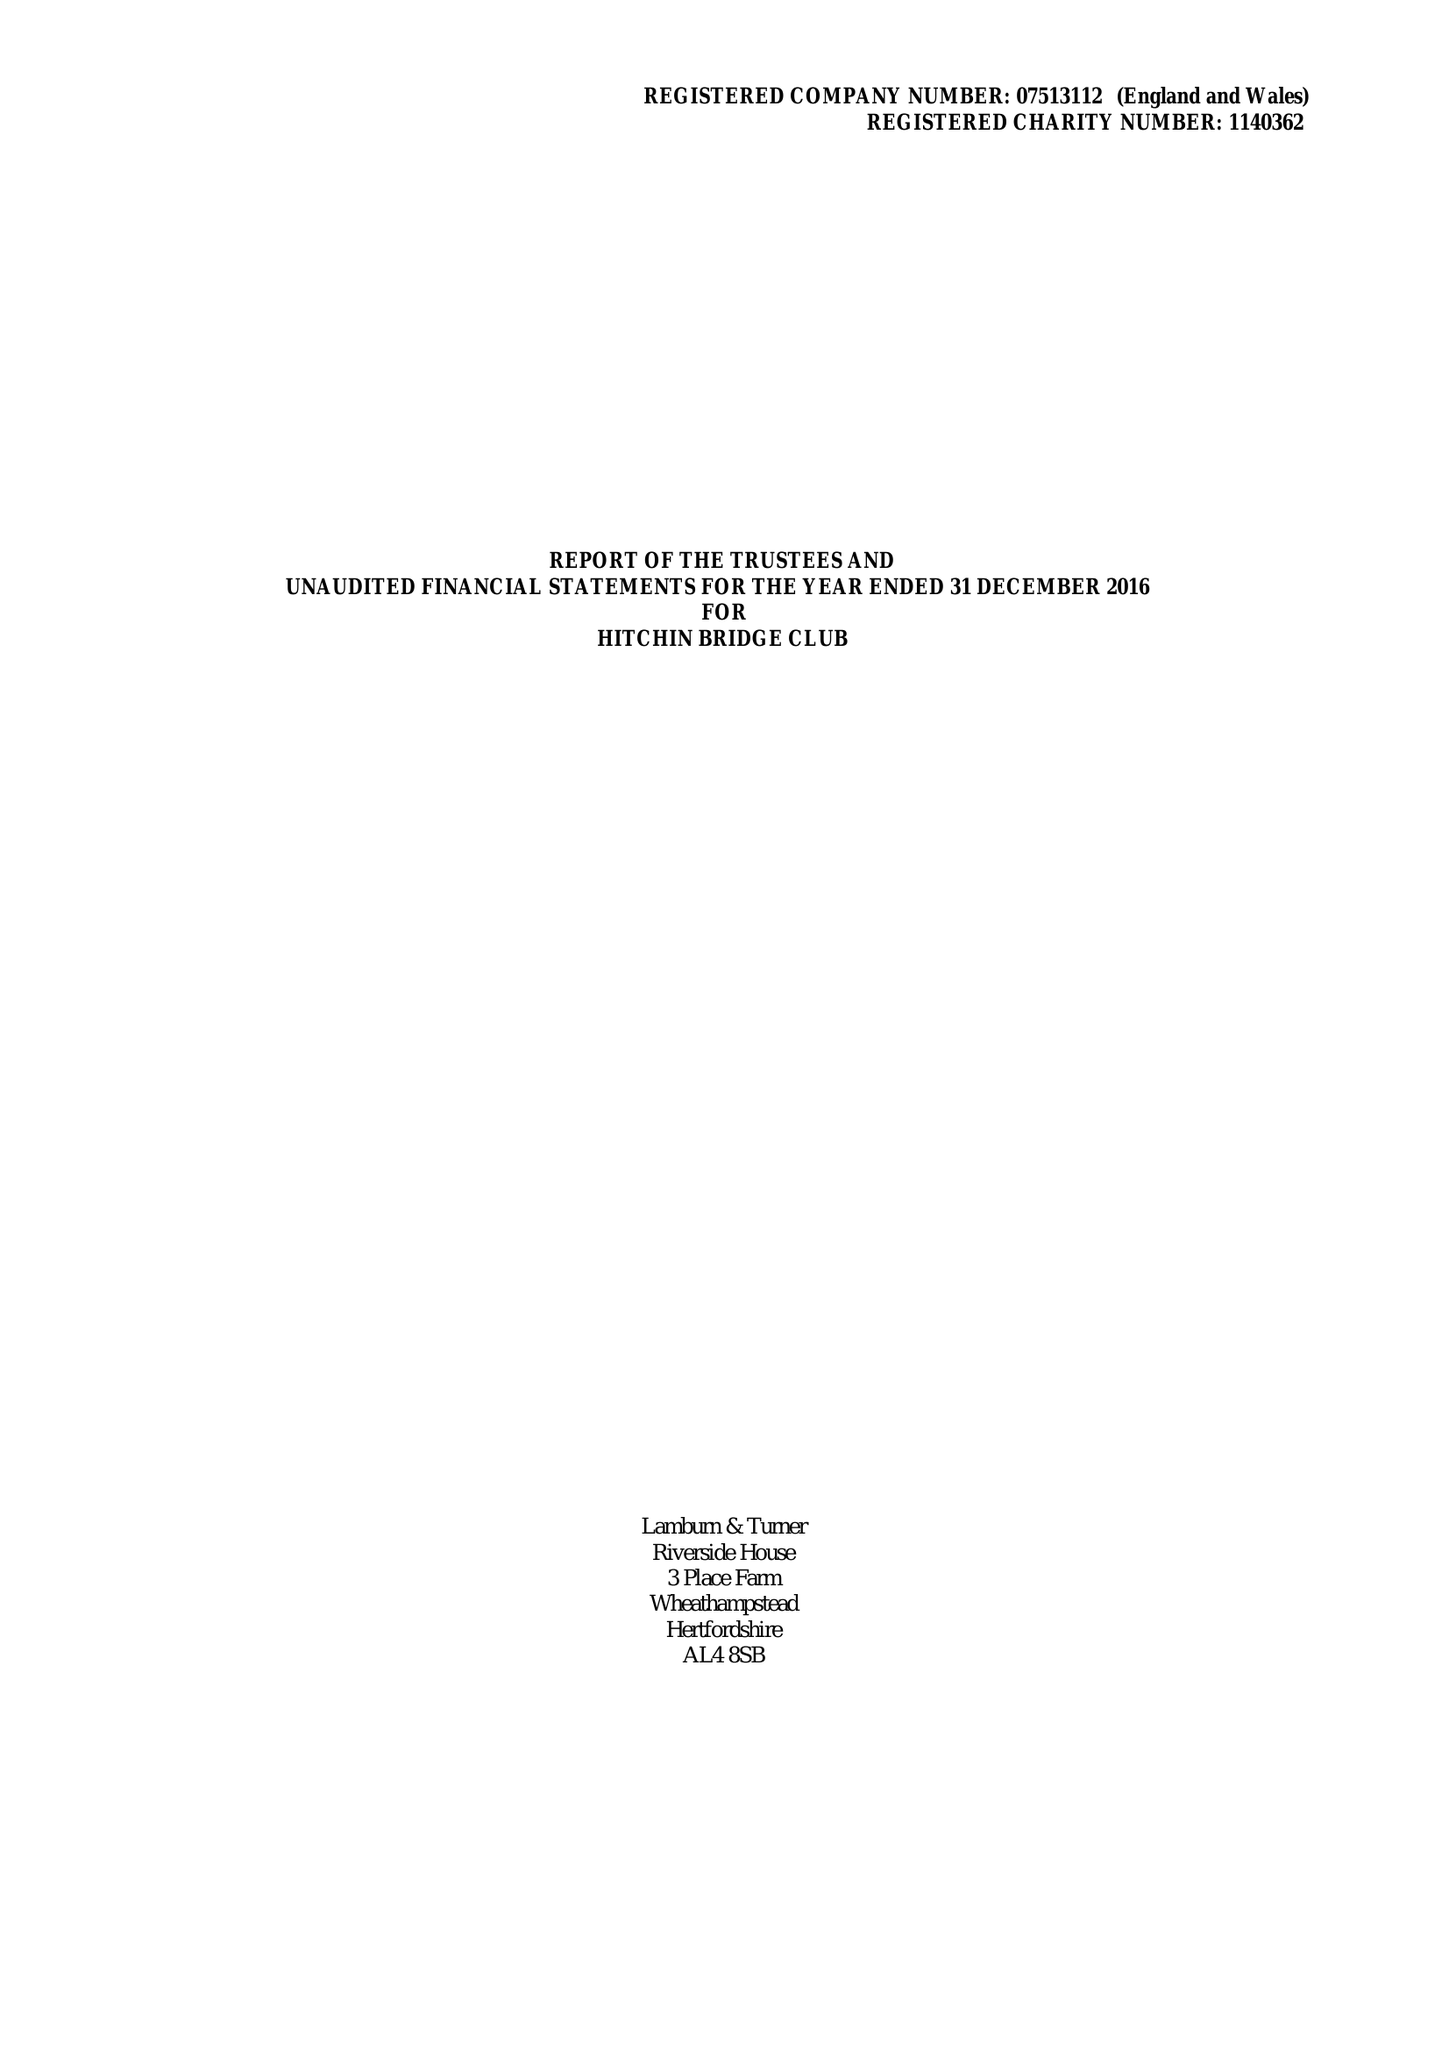What is the value for the address__street_line?
Answer the question using a single word or phrase. None 